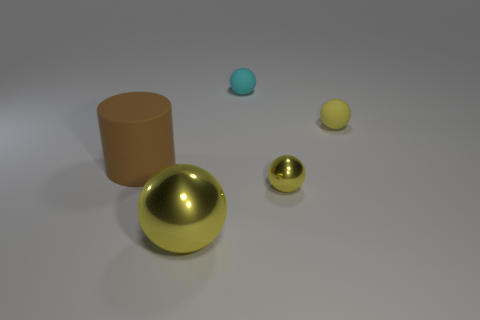How many objects are there in total, and can you describe their colors and shapes? There are five objects in total. Starting from the left, there's a large brown cylinder, a large gold sphere, a medium-sized aqua sphere, a medium-sized gold sphere, and a small yellow sphere. 